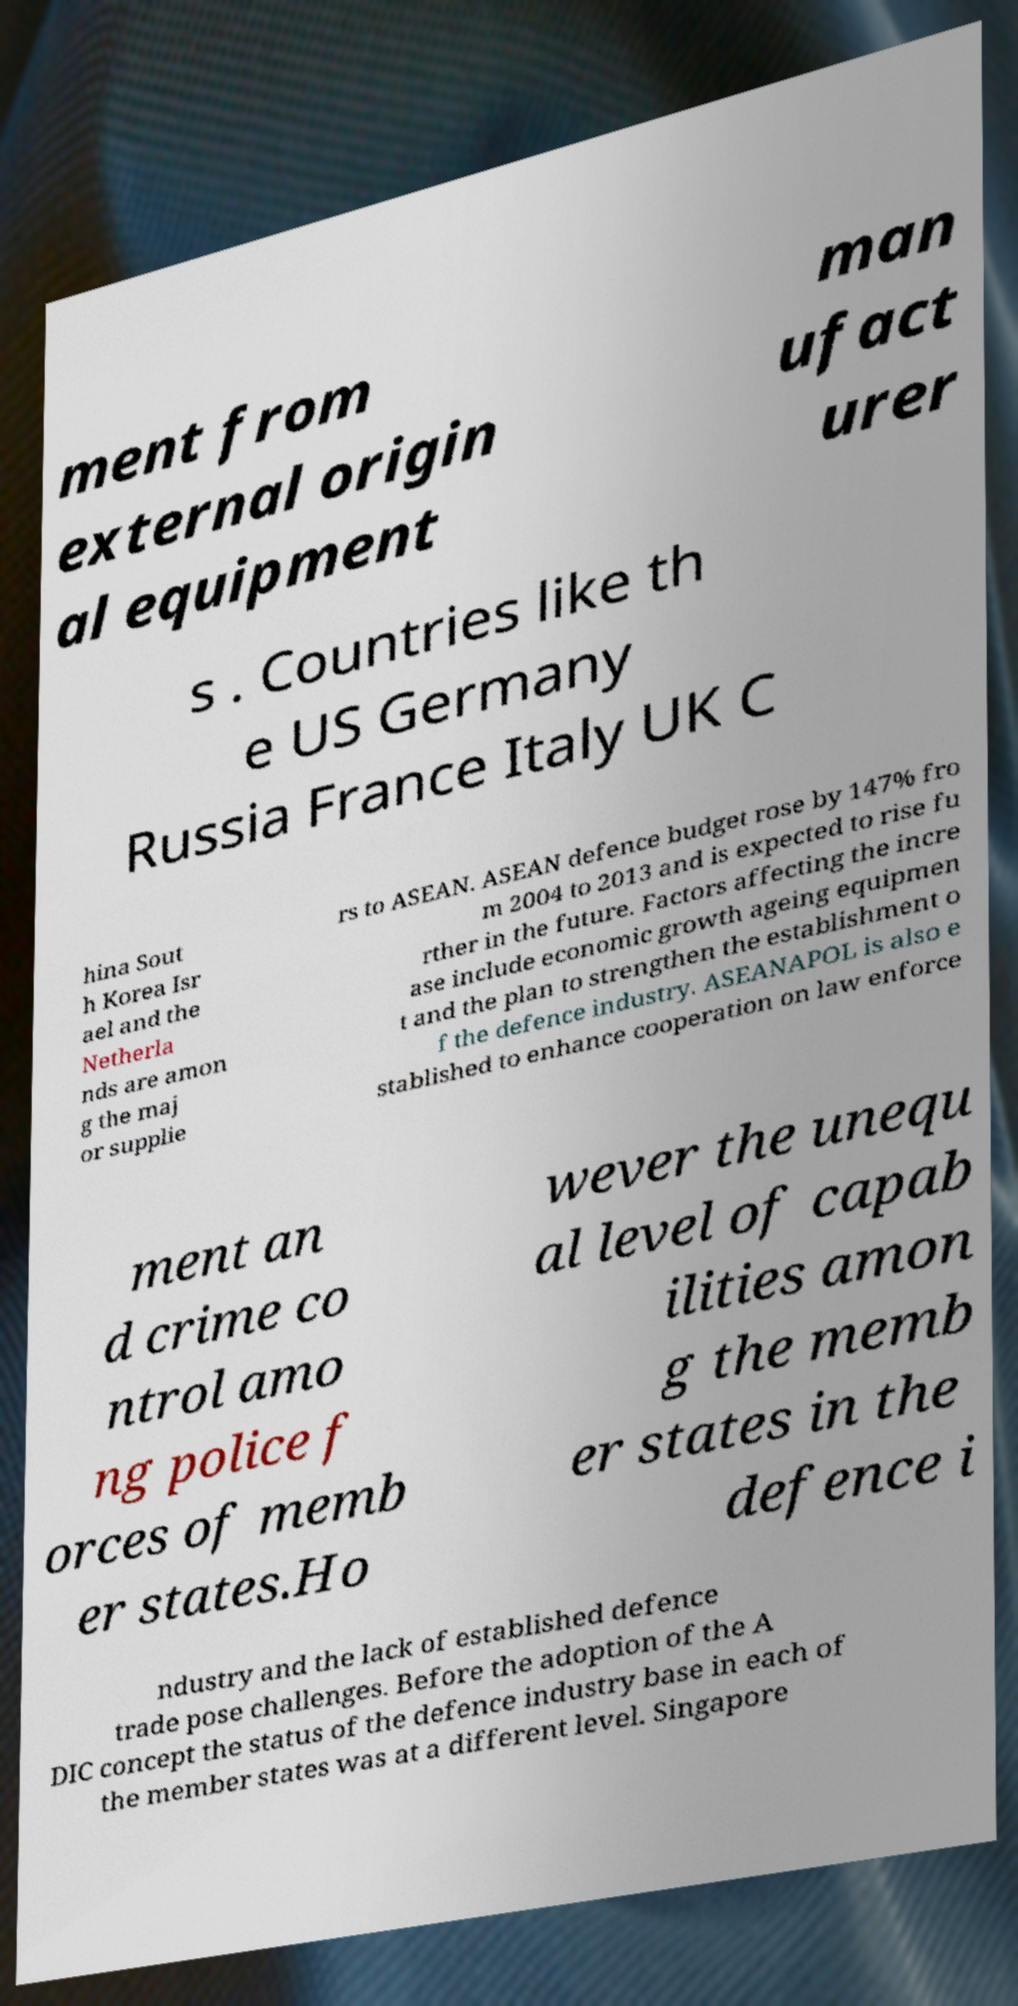Can you read and provide the text displayed in the image?This photo seems to have some interesting text. Can you extract and type it out for me? ment from external origin al equipment man ufact urer s . Countries like th e US Germany Russia France Italy UK C hina Sout h Korea Isr ael and the Netherla nds are amon g the maj or supplie rs to ASEAN. ASEAN defence budget rose by 147% fro m 2004 to 2013 and is expected to rise fu rther in the future. Factors affecting the incre ase include economic growth ageing equipmen t and the plan to strengthen the establishment o f the defence industry. ASEANAPOL is also e stablished to enhance cooperation on law enforce ment an d crime co ntrol amo ng police f orces of memb er states.Ho wever the unequ al level of capab ilities amon g the memb er states in the defence i ndustry and the lack of established defence trade pose challenges. Before the adoption of the A DIC concept the status of the defence industry base in each of the member states was at a different level. Singapore 